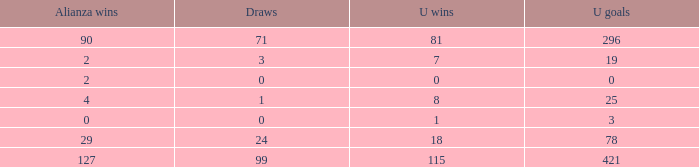What is the total number of U Wins, when Alianza Goals is "0", and when U Goals is greater than 3? 0.0. 